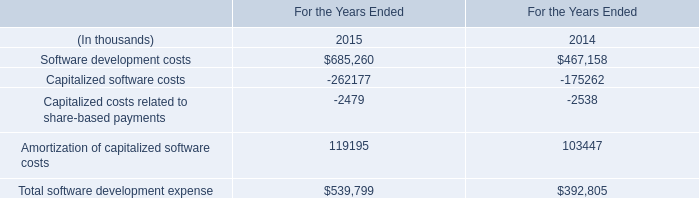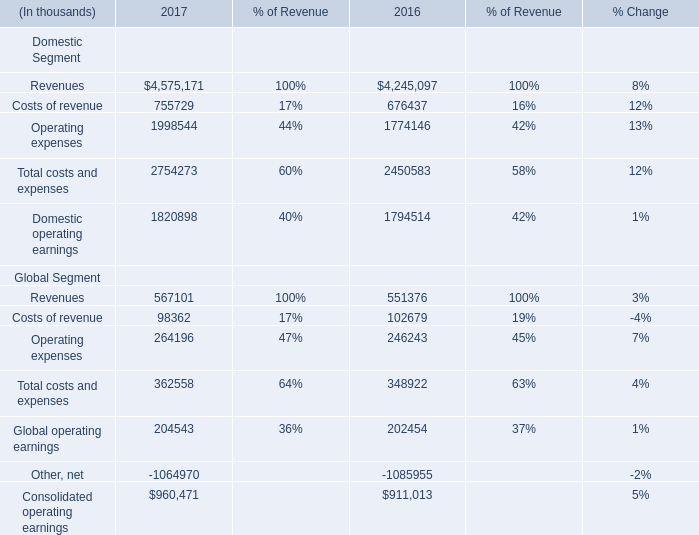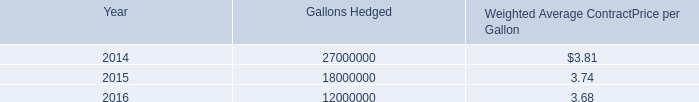What's the average of Operating expenses of 2017, and Software development costs of For the Years Ended 2014 ? 
Computations: ((1998544.0 + 467158.0) / 2)
Answer: 1232851.0. In the year with lowest amount of Operating expenses, what's the increasing rate of Costs of revenue? 
Computations: ((755729 - 676437) / 676437)
Answer: 0.11722. 